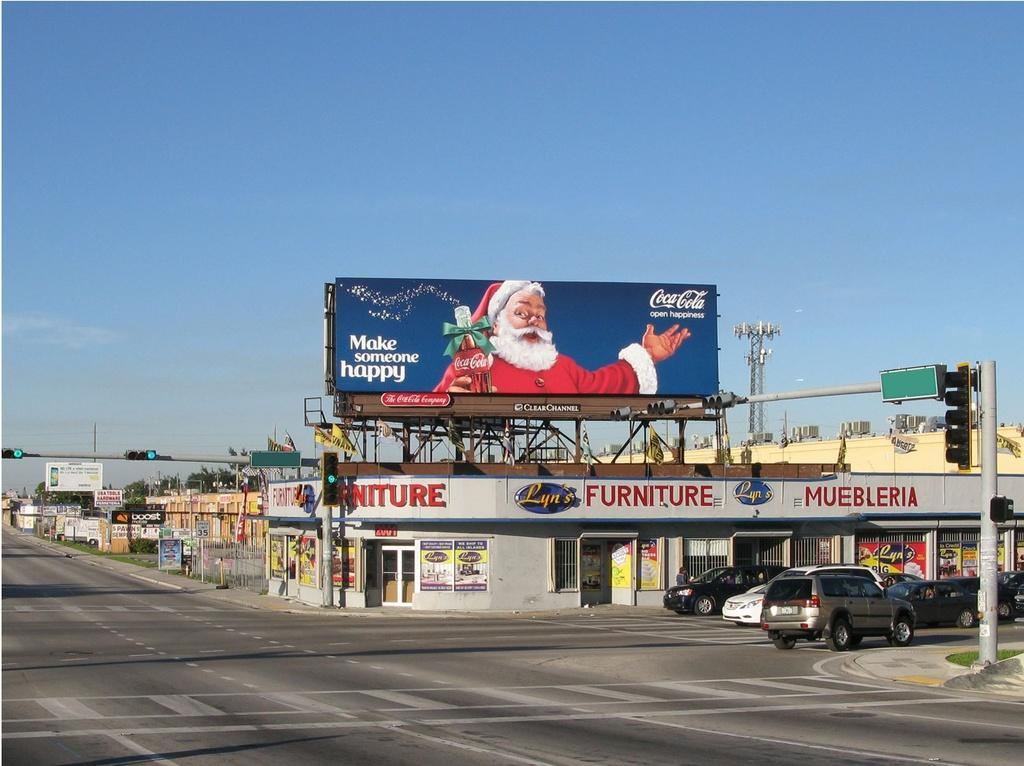<image>
Describe the image concisely. The Coca Cola sign on a furniture store on a street corner has the image of Santa on it. 